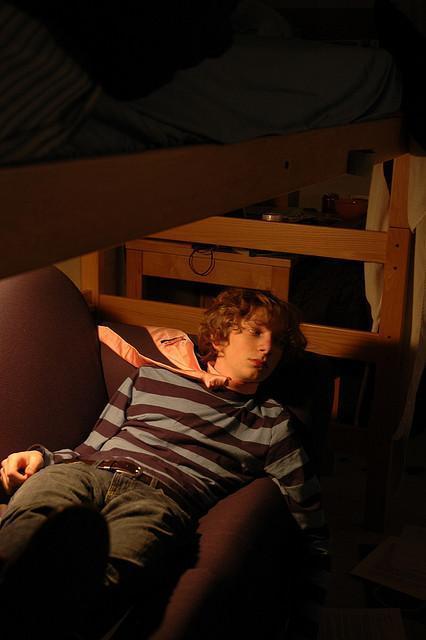How many boys are there?
Give a very brief answer. 1. 